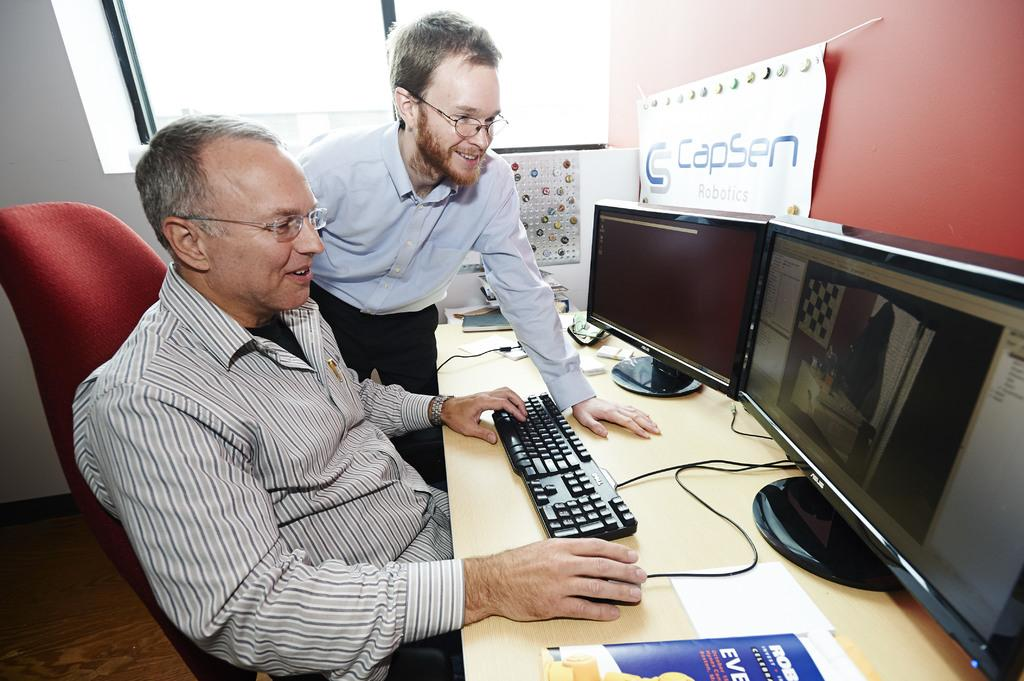<image>
Present a compact description of the photo's key features. Two men are working on a computer with a sign that says Capsen Robotics. 